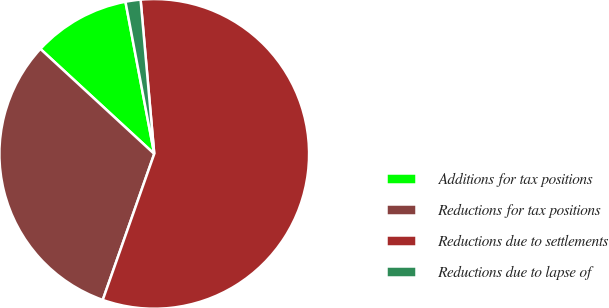<chart> <loc_0><loc_0><loc_500><loc_500><pie_chart><fcel>Additions for tax positions<fcel>Reductions for tax positions<fcel>Reductions due to settlements<fcel>Reductions due to lapse of<nl><fcel>10.17%<fcel>31.46%<fcel>56.8%<fcel>1.57%<nl></chart> 